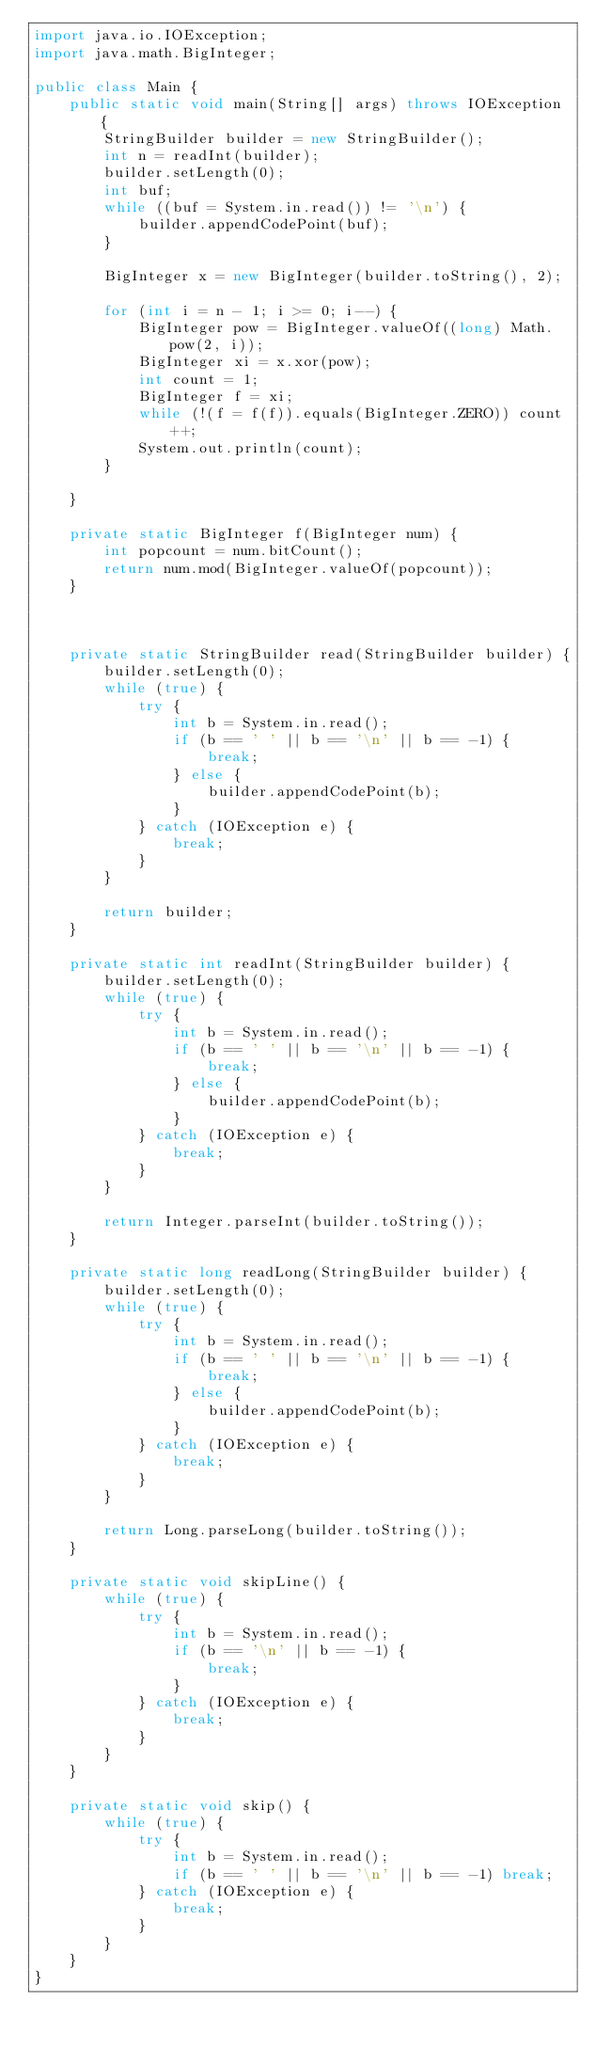Convert code to text. <code><loc_0><loc_0><loc_500><loc_500><_Java_>import java.io.IOException;
import java.math.BigInteger;

public class Main {
    public static void main(String[] args) throws IOException {
        StringBuilder builder = new StringBuilder();
        int n = readInt(builder);
        builder.setLength(0);
        int buf;
        while ((buf = System.in.read()) != '\n') {
            builder.appendCodePoint(buf);
        }

        BigInteger x = new BigInteger(builder.toString(), 2);

        for (int i = n - 1; i >= 0; i--) {
            BigInteger pow = BigInteger.valueOf((long) Math.pow(2, i));
            BigInteger xi = x.xor(pow);
            int count = 1;
            BigInteger f = xi;
            while (!(f = f(f)).equals(BigInteger.ZERO)) count++;
            System.out.println(count);
        }

    }

    private static BigInteger f(BigInteger num) {
        int popcount = num.bitCount();
        return num.mod(BigInteger.valueOf(popcount));
    }



    private static StringBuilder read(StringBuilder builder) {
        builder.setLength(0);
        while (true) {
            try {
                int b = System.in.read();
                if (b == ' ' || b == '\n' || b == -1) {
                    break;
                } else {
                    builder.appendCodePoint(b);
                }
            } catch (IOException e) {
                break;
            }
        }

        return builder;
    }

    private static int readInt(StringBuilder builder) {
        builder.setLength(0);
        while (true) {
            try {
                int b = System.in.read();
                if (b == ' ' || b == '\n' || b == -1) {
                    break;
                } else {
                    builder.appendCodePoint(b);
                }
            } catch (IOException e) {
                break;
            }
        }

        return Integer.parseInt(builder.toString());
    }

    private static long readLong(StringBuilder builder) {
        builder.setLength(0);
        while (true) {
            try {
                int b = System.in.read();
                if (b == ' ' || b == '\n' || b == -1) {
                    break;
                } else {
                    builder.appendCodePoint(b);
                }
            } catch (IOException e) {
                break;
            }
        }

        return Long.parseLong(builder.toString());
    }

    private static void skipLine() {
        while (true) {
            try {
                int b = System.in.read();
                if (b == '\n' || b == -1) {
                    break;
                }
            } catch (IOException e) {
                break;
            }
        }
    }

    private static void skip() {
        while (true) {
            try {
                int b = System.in.read();
                if (b == ' ' || b == '\n' || b == -1) break;
            } catch (IOException e) {
                break;
            }
        }
    }
}
</code> 